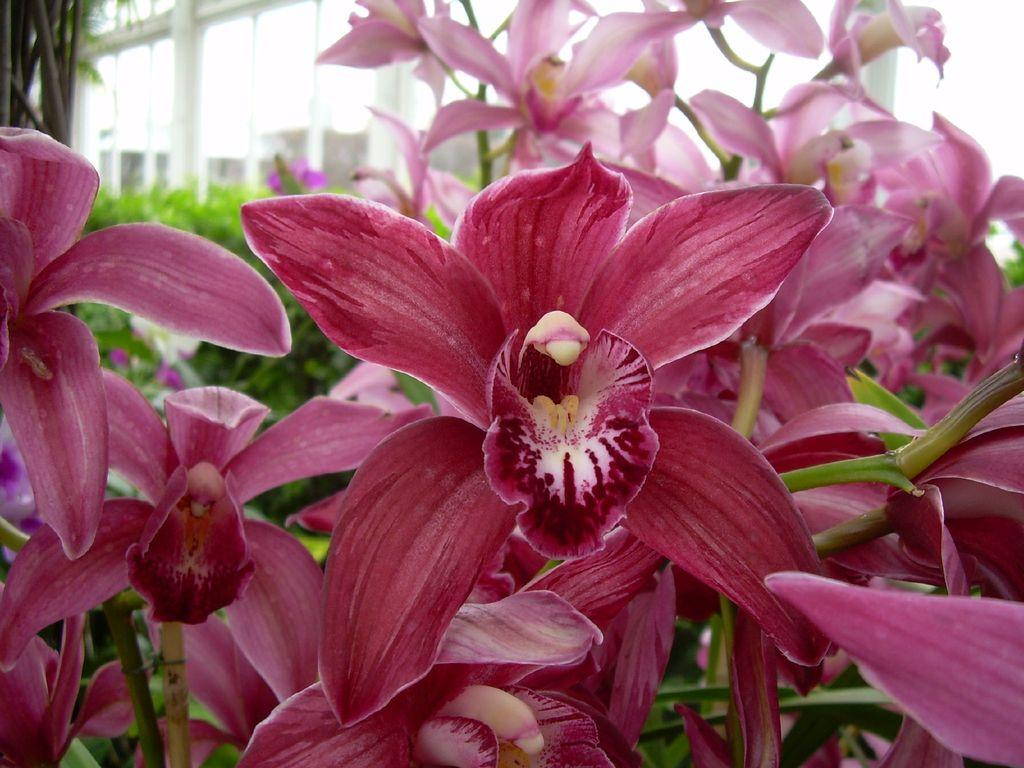Where was the picture taken? The picture was taken outside. What can be seen in the foreground of the image? There are pink colored flowers in the foreground of the image. What is visible in the background of the image? There are plants, a tree, and a building in the background of the image. What type of music is the band playing in the background of the image? There is no band present in the image, so it is not possible to determine what type of music they might be playing. 